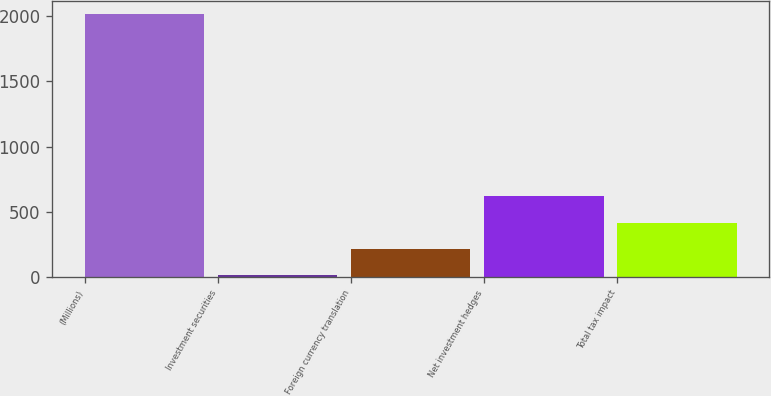Convert chart to OTSL. <chart><loc_0><loc_0><loc_500><loc_500><bar_chart><fcel>(Millions)<fcel>Investment securities<fcel>Foreign currency translation<fcel>Net investment hedges<fcel>Total tax impact<nl><fcel>2014<fcel>19<fcel>218.5<fcel>617.5<fcel>418<nl></chart> 